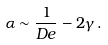<formula> <loc_0><loc_0><loc_500><loc_500>\alpha \sim \frac { 1 } { D e } - 2 \gamma \, .</formula> 